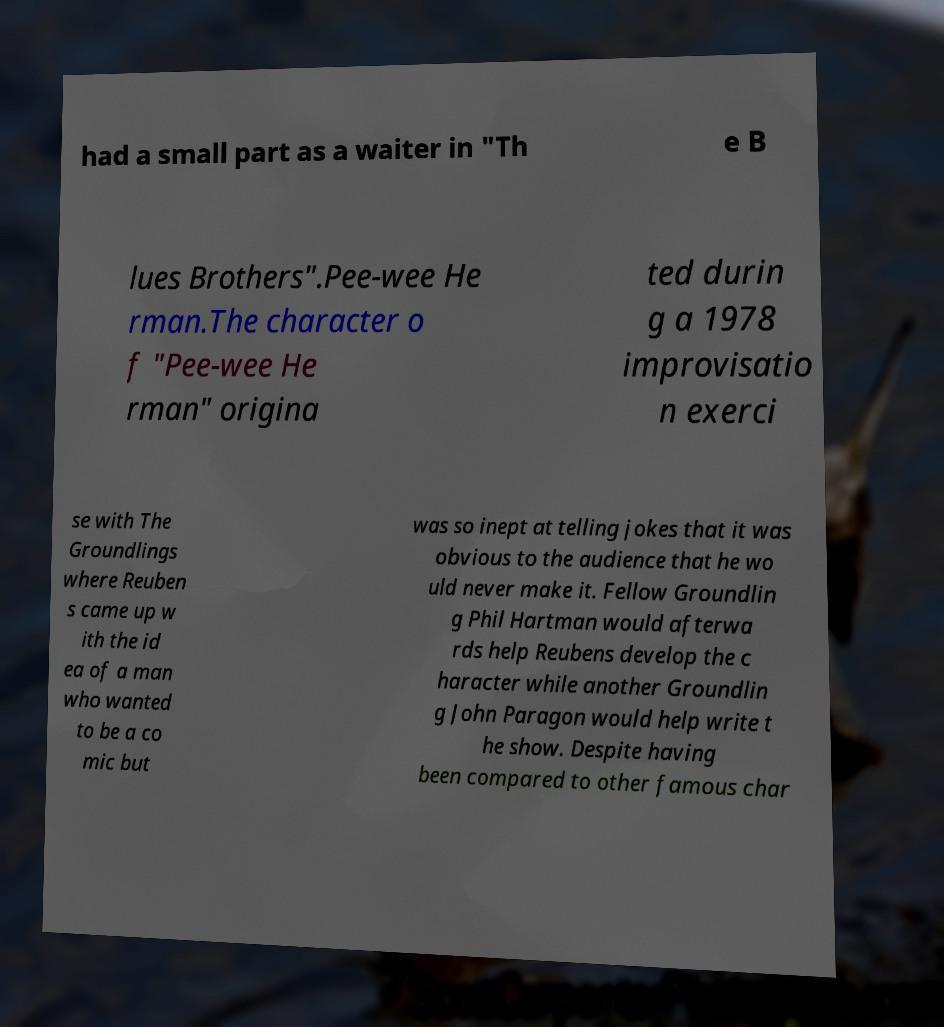For documentation purposes, I need the text within this image transcribed. Could you provide that? had a small part as a waiter in "Th e B lues Brothers".Pee-wee He rman.The character o f "Pee-wee He rman" origina ted durin g a 1978 improvisatio n exerci se with The Groundlings where Reuben s came up w ith the id ea of a man who wanted to be a co mic but was so inept at telling jokes that it was obvious to the audience that he wo uld never make it. Fellow Groundlin g Phil Hartman would afterwa rds help Reubens develop the c haracter while another Groundlin g John Paragon would help write t he show. Despite having been compared to other famous char 